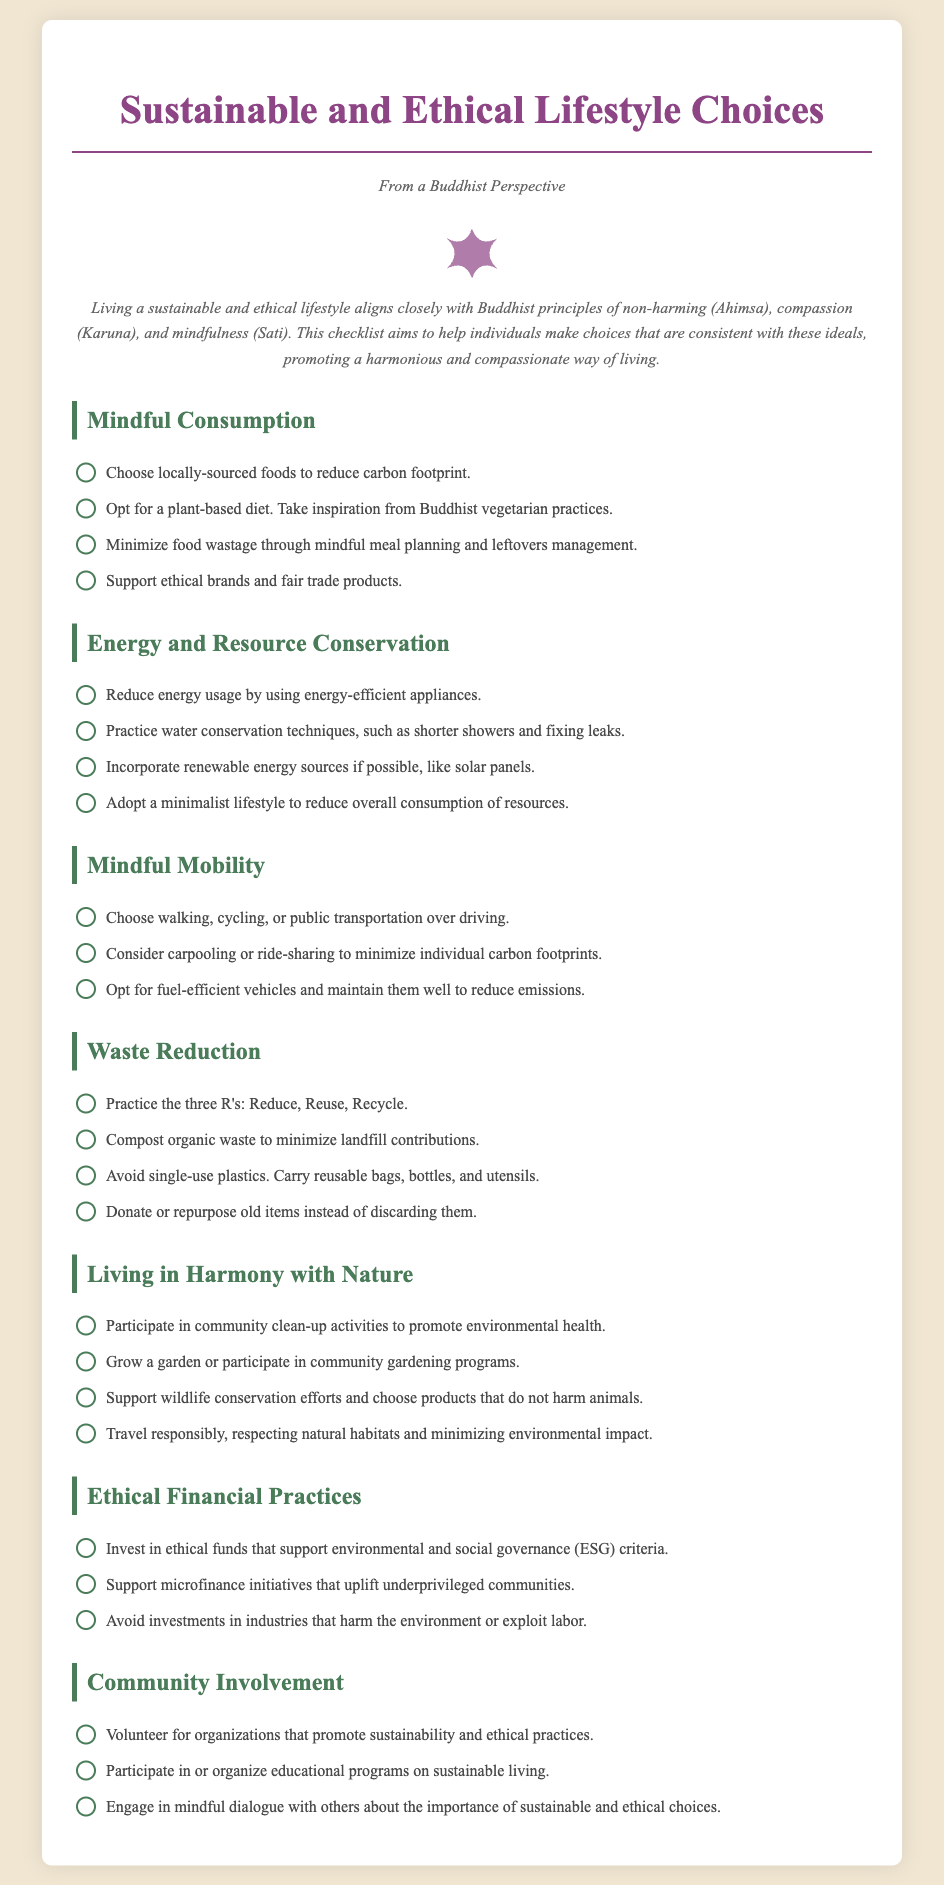What is the title of the checklist? The title of the checklist is presented prominently at the top of the document.
Answer: Sustainable and Ethical Lifestyle Choices How many sections are in the checklist? The checklist is divided into several specific sections, each addressing different aspects of sustainable living.
Answer: Six What principle aligns with mindful consumption? The checklist mentions a specific principle related to mindful consumption as part of its foundation.
Answer: Non-harming (Ahimsa) What is one recommended practice under Waste Reduction? The checklist lists specific practices to reduce waste in a designated section.
Answer: Compost organic waste Which activity promotes living in harmony with nature? The checklist outlines specific activities that contribute to harmony with nature in its corresponding section.
Answer: Participate in community clean-up activities What is suggested to minimize energy usage? The checklist provides an actionable item focused on reducing energy consumption.
Answer: Using energy-efficient appliances How can one support underprivileged communities financially? The checklist includes options for ethical financial practices in support of communities.
Answer: Support microfinance initiatives What is encouraged to promote sustainability in the community? The checklist encourages participation in community activities relevant to sustainability.
Answer: Volunteer for organizations that promote sustainability and ethical practices 